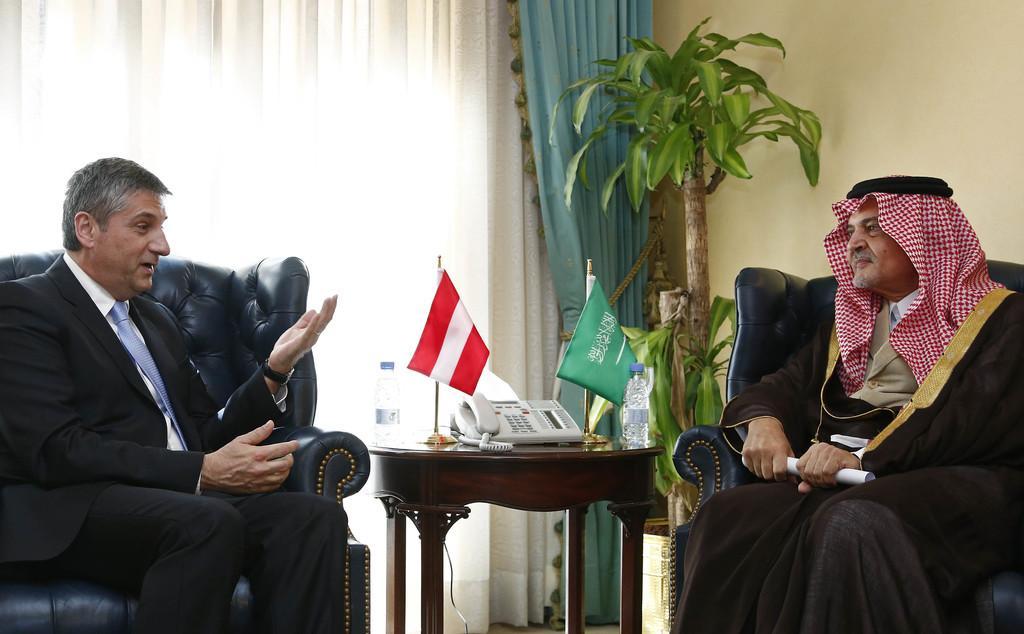In one or two sentences, can you explain what this image depicts? In this picture we can see two people are seated on the chair and they are talking to each other in front of them we can find flags, telephone, bottles on the table, and also we can see a plant and curtains. 